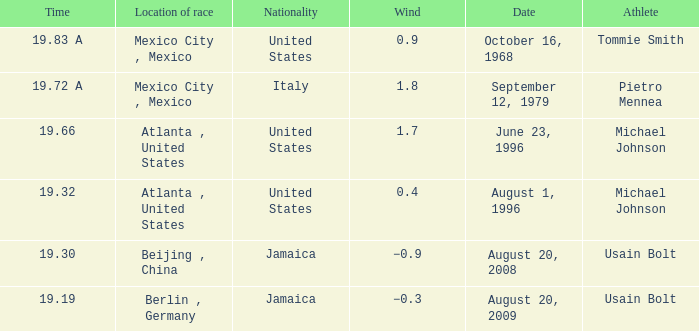Who's the athlete with a wind of 1.7 and from the United States? Michael Johnson. 